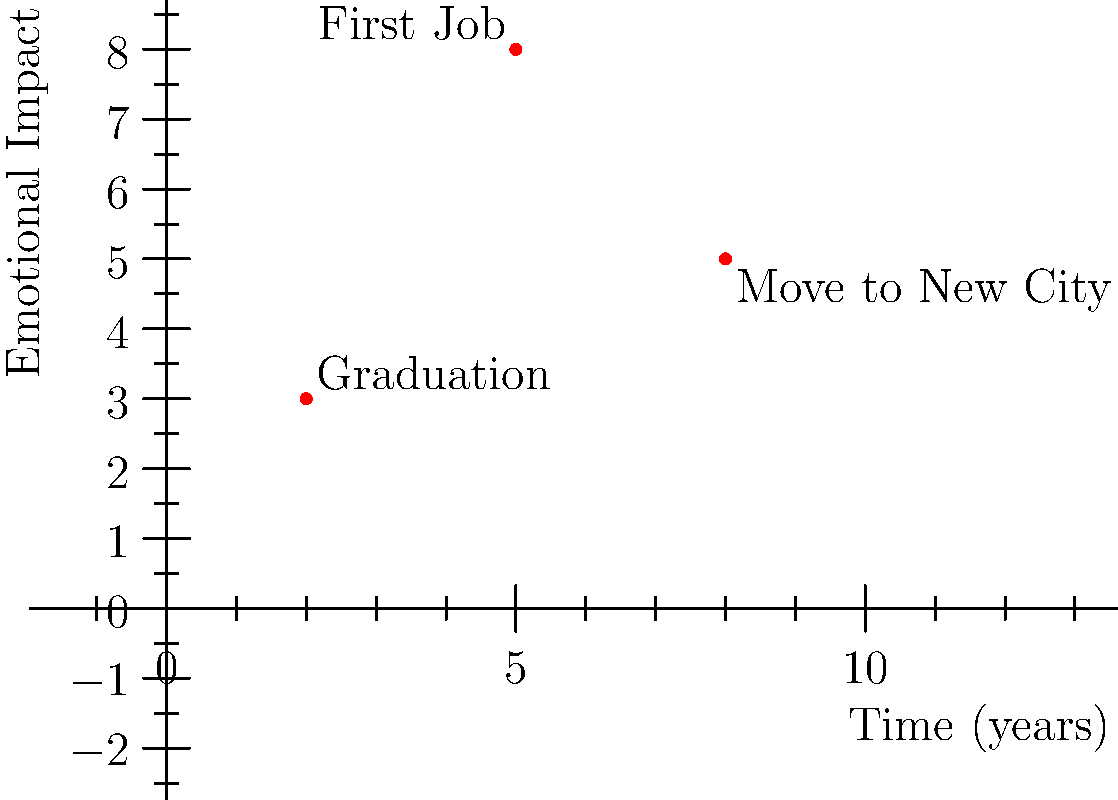On this personal timeline graph, significant life events are plotted based on their emotional impact and the time they occurred. The x-axis represents time in years, and the y-axis represents the emotional impact on a scale of 1 to 10. If starting your first job was the most emotionally impactful event and occurred 5 years into your timeline, what are its coordinates on this graph? To find the coordinates of the point representing the first job, we need to analyze the graph and the information given:

1. The x-axis represents time in years.
2. The y-axis represents emotional impact on a scale of 1 to 10.
3. We're told that starting the first job was the most emotionally impactful event.
4. This event occurred 5 years into the timeline.

Looking at the graph:
1. There are three points plotted, representing significant life events.
2. The point with the highest y-value (emotional impact) is at $(5,8)$.
3. This point aligns with the x-value of 5, which matches the information that the first job occurred 5 years into the timeline.

Therefore, the coordinates of the point representing the first job are $(5,8)$.

This point signifies that 5 years into your personal timeline, you experienced an event (starting your first job) that had an emotional impact of 8 out of 10, making it the most impactful event shown on the graph.
Answer: $(5,8)$ 